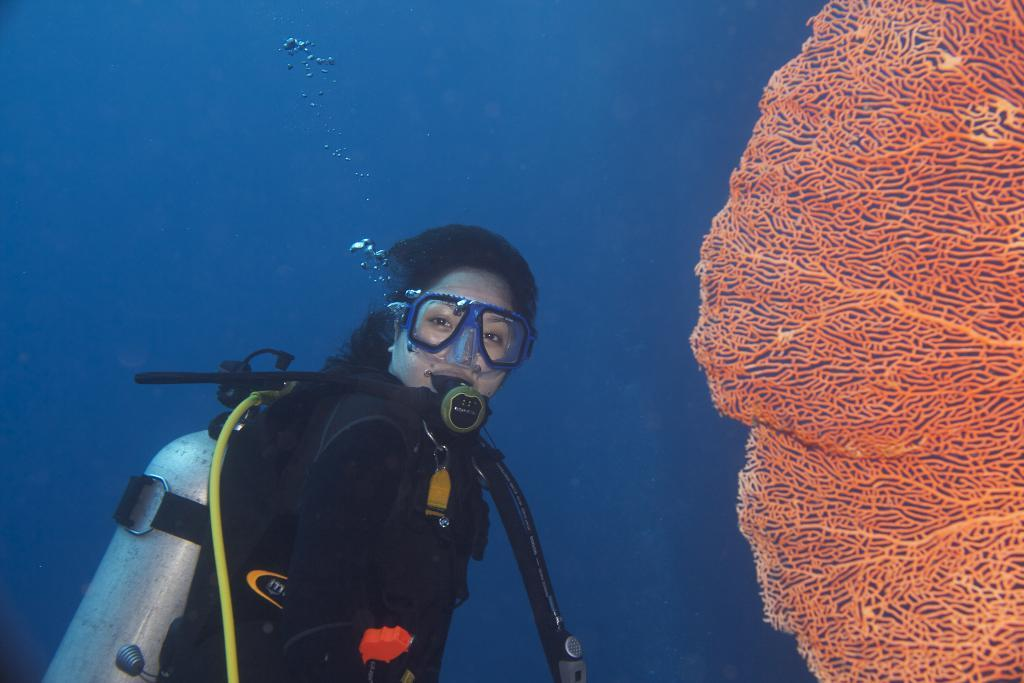Who is the person in the image? There is a woman in the image. What is the woman wearing? The woman is wearing a black jacket. What activity is the woman engaged in? The woman is scuba diving. What object can be seen in the image besides the woman? There is a net in the image. What color is the net? The net is orange in color. What can be seen in the background of the image? The background of the image is blue. What type of afterthought is the woman having while scuba diving? There is no indication in the image of any afterthoughts or adjustments the woman might be having while scuba diving. What kind of apparatus is the woman using to adjust her scuba diving equipment? There is no apparatus visible in the image that the woman might be using to adjust her scuba diving equipment. 